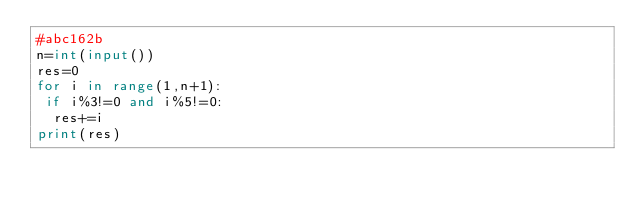<code> <loc_0><loc_0><loc_500><loc_500><_Python_>#abc162b
n=int(input())
res=0
for i in range(1,n+1):
 if i%3!=0 and i%5!=0:
  res+=i
print(res)
</code> 